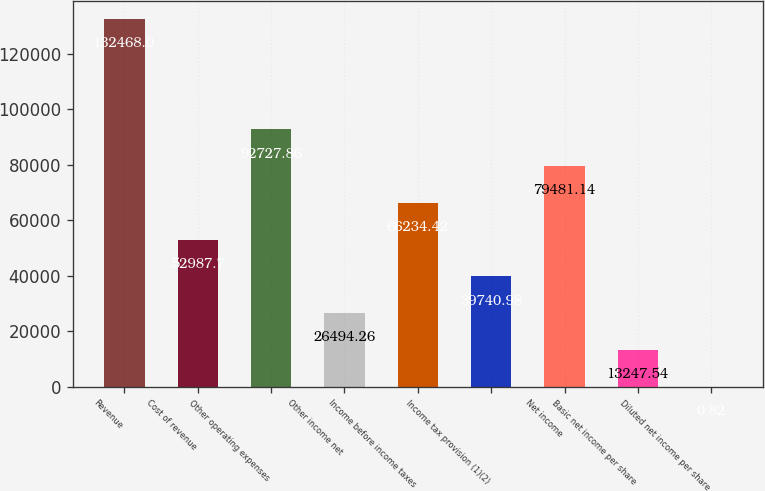<chart> <loc_0><loc_0><loc_500><loc_500><bar_chart><fcel>Revenue<fcel>Cost of revenue<fcel>Other operating expenses<fcel>Other income net<fcel>Income before income taxes<fcel>Income tax provision (1)(2)<fcel>Net income<fcel>Basic net income per share<fcel>Diluted net income per share<nl><fcel>132468<fcel>52987.7<fcel>92727.9<fcel>26494.3<fcel>66234.4<fcel>39741<fcel>79481.1<fcel>13247.5<fcel>0.82<nl></chart> 